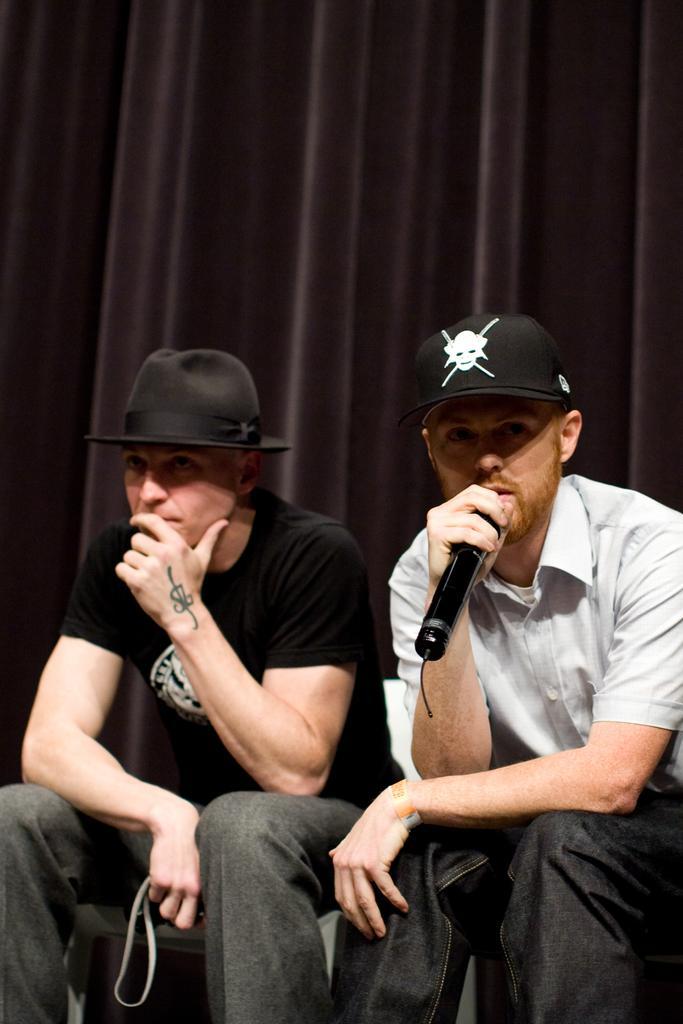In one or two sentences, can you explain what this image depicts? A man is sitting and speaking with a mic in hand wears a black cap. There is another man sitting beside him wearing a black color hat. 